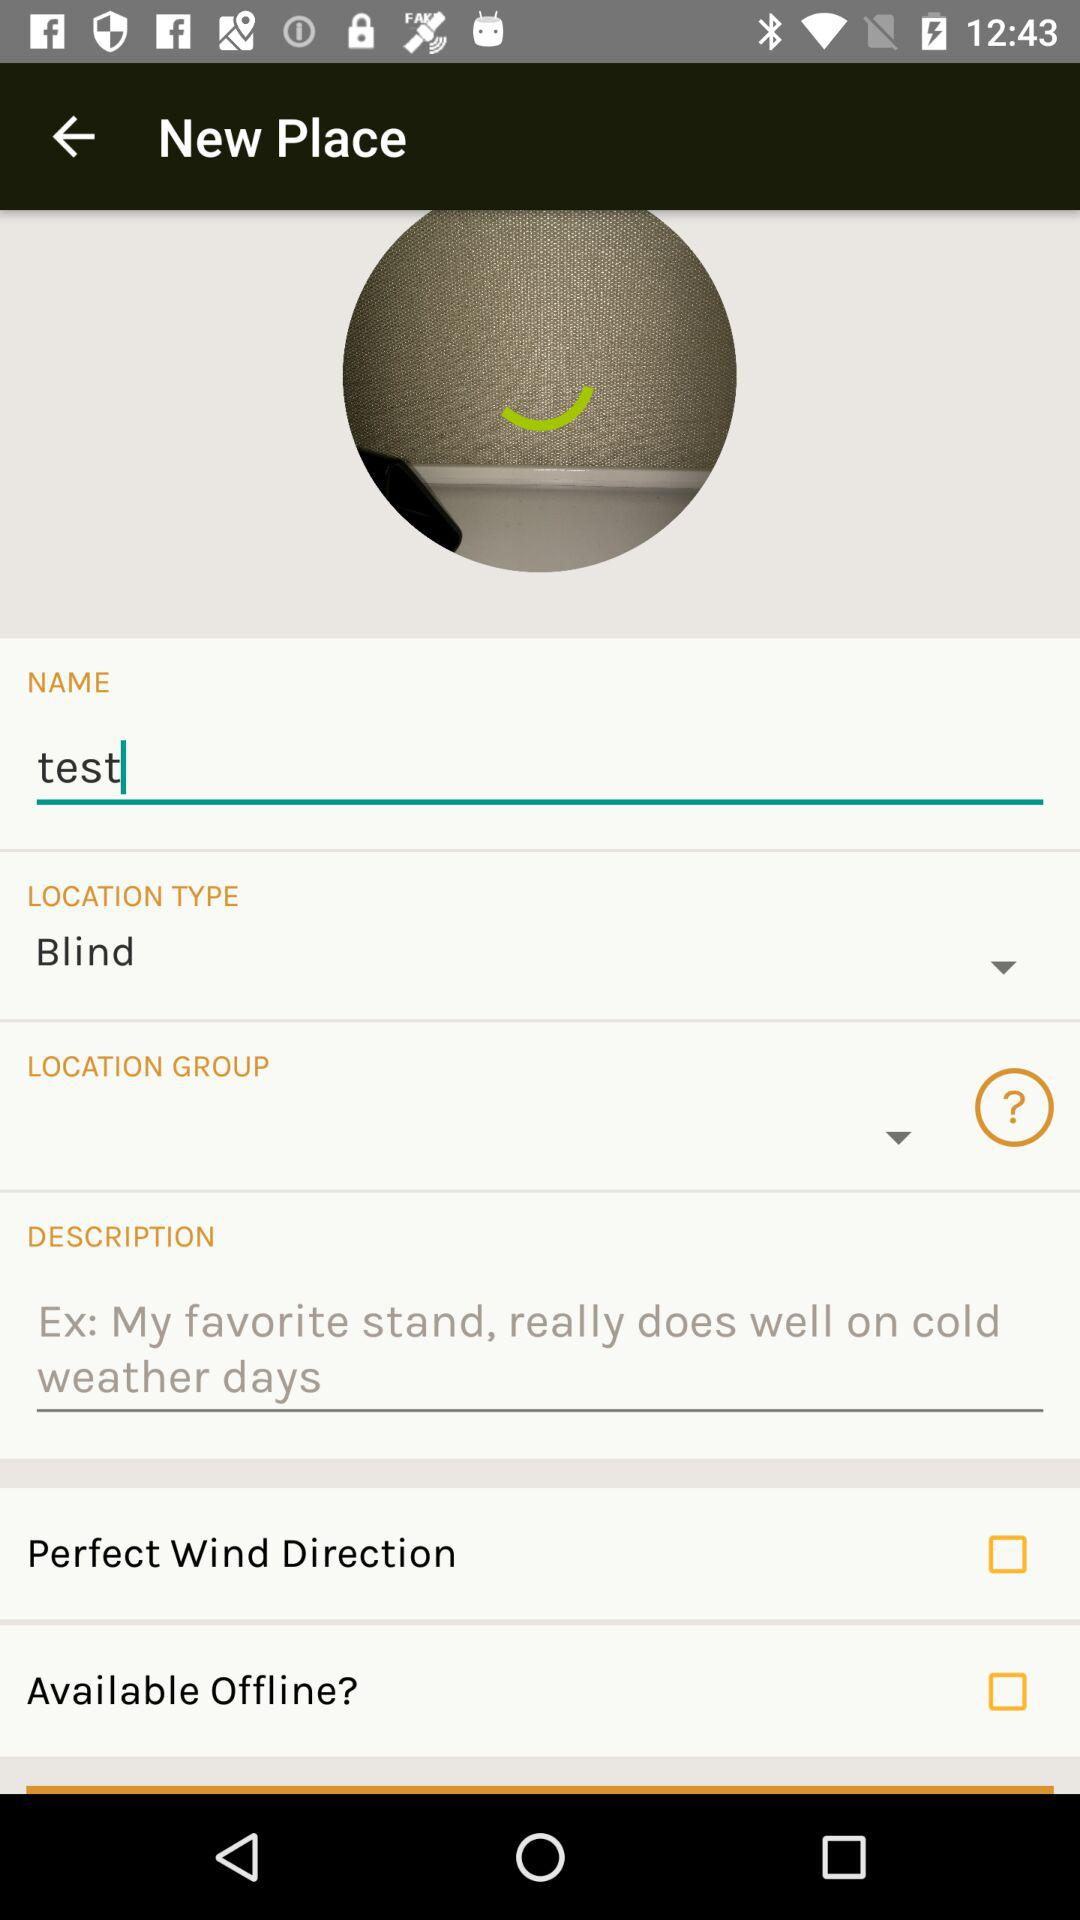What is the name? The name is "test". 